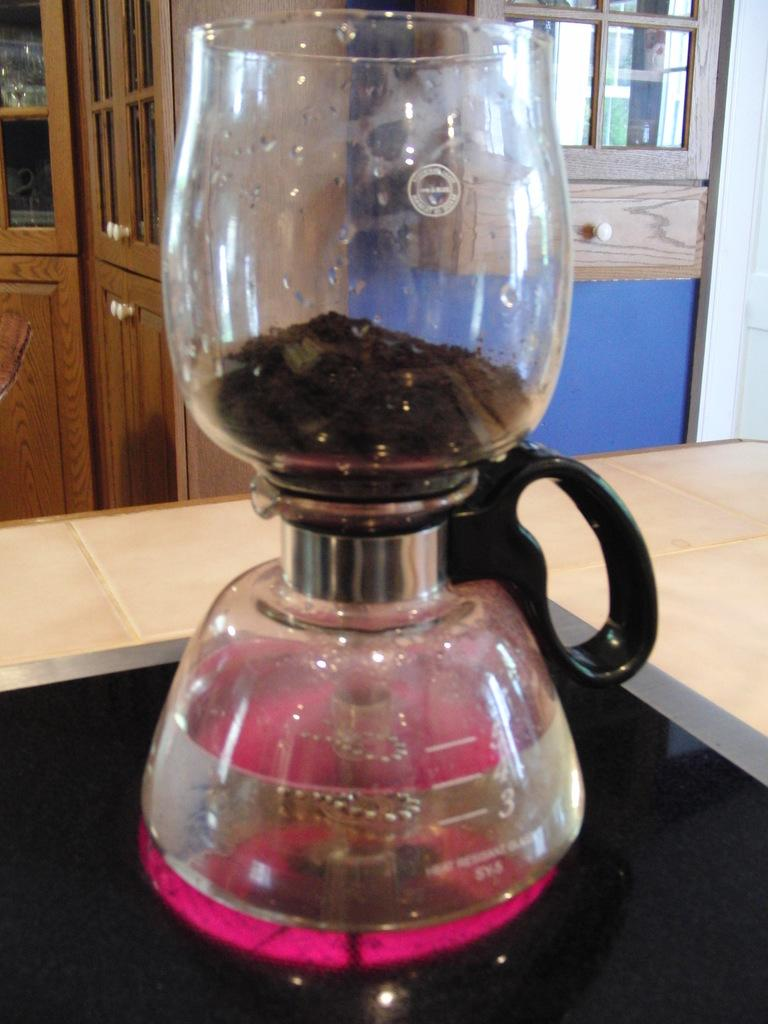Provide a one-sentence caption for the provided image. A beaker with a glass on top which is heat resistant, where there is pink liquid below the 5, 4, and 3 lines. 